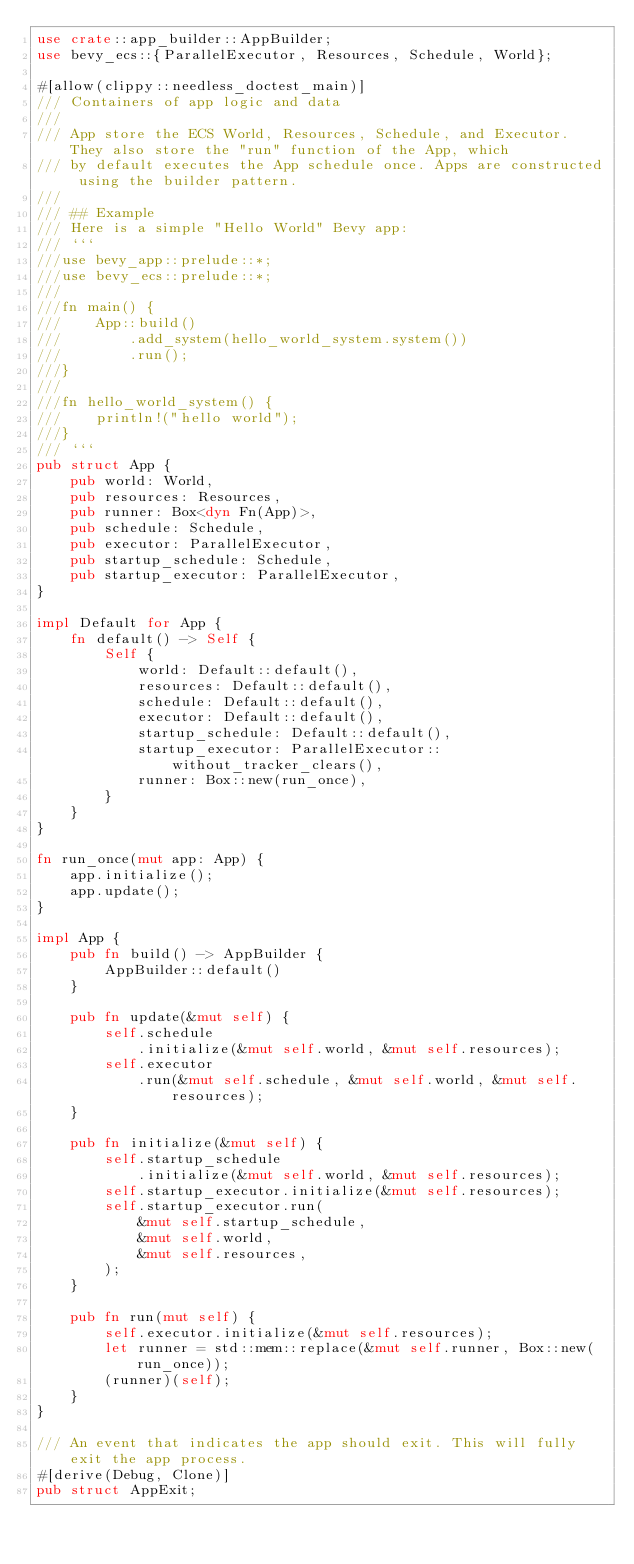Convert code to text. <code><loc_0><loc_0><loc_500><loc_500><_Rust_>use crate::app_builder::AppBuilder;
use bevy_ecs::{ParallelExecutor, Resources, Schedule, World};

#[allow(clippy::needless_doctest_main)]
/// Containers of app logic and data
///
/// App store the ECS World, Resources, Schedule, and Executor. They also store the "run" function of the App, which
/// by default executes the App schedule once. Apps are constructed using the builder pattern.
///
/// ## Example
/// Here is a simple "Hello World" Bevy app:
/// ```
///use bevy_app::prelude::*;
///use bevy_ecs::prelude::*;
///
///fn main() {
///    App::build()
///        .add_system(hello_world_system.system())
///        .run();
///}
///
///fn hello_world_system() {
///    println!("hello world");
///}
/// ```
pub struct App {
    pub world: World,
    pub resources: Resources,
    pub runner: Box<dyn Fn(App)>,
    pub schedule: Schedule,
    pub executor: ParallelExecutor,
    pub startup_schedule: Schedule,
    pub startup_executor: ParallelExecutor,
}

impl Default for App {
    fn default() -> Self {
        Self {
            world: Default::default(),
            resources: Default::default(),
            schedule: Default::default(),
            executor: Default::default(),
            startup_schedule: Default::default(),
            startup_executor: ParallelExecutor::without_tracker_clears(),
            runner: Box::new(run_once),
        }
    }
}

fn run_once(mut app: App) {
    app.initialize();
    app.update();
}

impl App {
    pub fn build() -> AppBuilder {
        AppBuilder::default()
    }

    pub fn update(&mut self) {
        self.schedule
            .initialize(&mut self.world, &mut self.resources);
        self.executor
            .run(&mut self.schedule, &mut self.world, &mut self.resources);
    }

    pub fn initialize(&mut self) {
        self.startup_schedule
            .initialize(&mut self.world, &mut self.resources);
        self.startup_executor.initialize(&mut self.resources);
        self.startup_executor.run(
            &mut self.startup_schedule,
            &mut self.world,
            &mut self.resources,
        );
    }

    pub fn run(mut self) {
        self.executor.initialize(&mut self.resources);
        let runner = std::mem::replace(&mut self.runner, Box::new(run_once));
        (runner)(self);
    }
}

/// An event that indicates the app should exit. This will fully exit the app process.
#[derive(Debug, Clone)]
pub struct AppExit;
</code> 